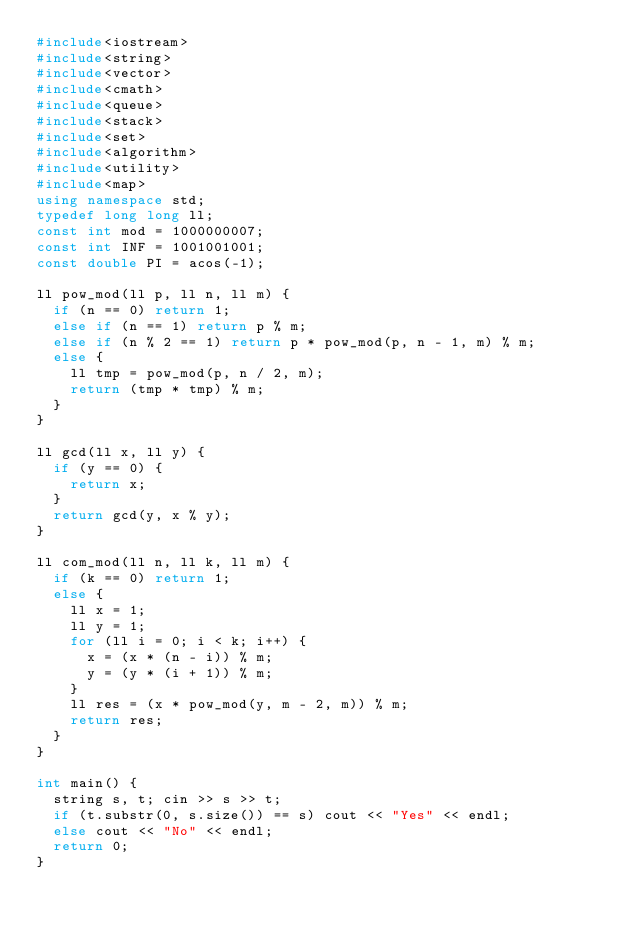<code> <loc_0><loc_0><loc_500><loc_500><_C++_>#include<iostream>
#include<string>
#include<vector>
#include<cmath>
#include<queue>
#include<stack>
#include<set>
#include<algorithm>
#include<utility>
#include<map>
using namespace std;
typedef long long ll;
const int mod = 1000000007;
const int INF = 1001001001;
const double PI = acos(-1);

ll pow_mod(ll p, ll n, ll m) {
	if (n == 0) return 1;
	else if (n == 1) return p % m;
	else if (n % 2 == 1) return p * pow_mod(p, n - 1, m) % m;
	else {
		ll tmp = pow_mod(p, n / 2, m);
		return (tmp * tmp) % m;
	}
}

ll gcd(ll x, ll y) {
	if (y == 0) {
		return x;
	}
	return gcd(y, x % y);
}

ll com_mod(ll n, ll k, ll m) {
	if (k == 0) return 1;
	else {
		ll x = 1;
		ll y = 1;
		for (ll i = 0; i < k; i++) {
			x = (x * (n - i)) % m;
			y = (y * (i + 1)) % m;
		}
		ll res = (x * pow_mod(y, m - 2, m)) % m;
		return res;
	}
}

int main() {
	string s, t; cin >> s >> t;
	if (t.substr(0, s.size()) == s) cout << "Yes" << endl;
	else cout << "No" << endl;
	return 0;
}</code> 